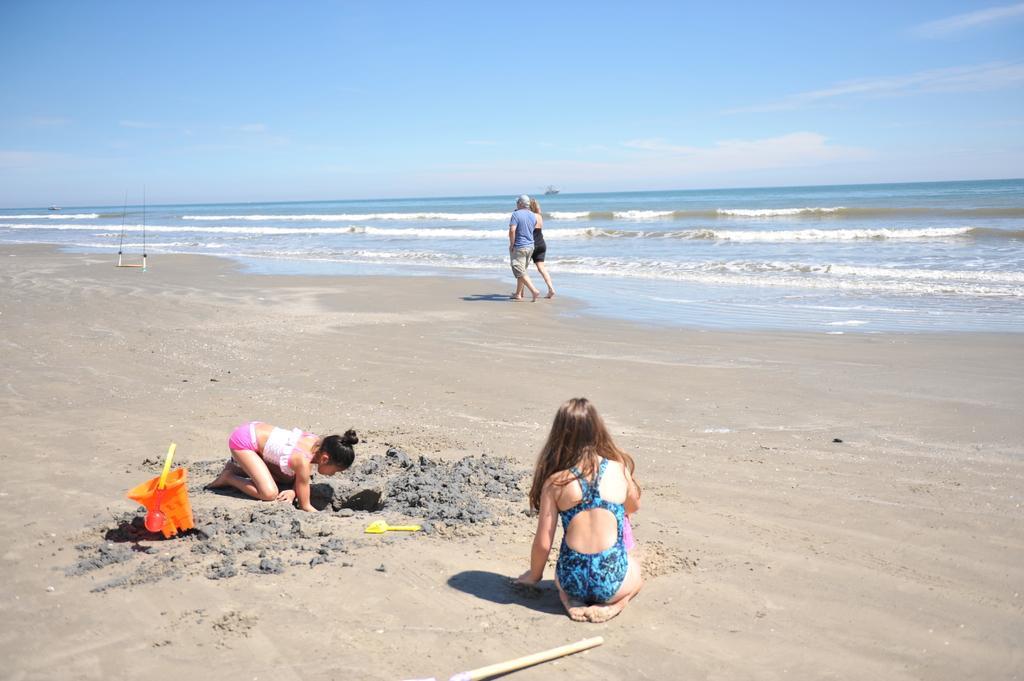Can you describe this image briefly? In this image I can see four persons on the beach. In the background I can see the ocean. On the top I can see the blue sky. This image is taken on a sandy beach. 